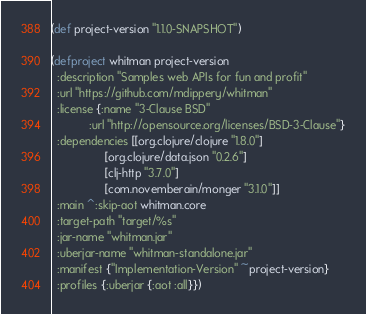Convert code to text. <code><loc_0><loc_0><loc_500><loc_500><_Clojure_>(def project-version "1.1.0-SNAPSHOT")

(defproject whitman project-version
  :description "Samples web APIs for fun and profit"
  :url "https://github.com/mdippery/whitman"
  :license {:name "3-Clause BSD"
            :url "http://opensource.org/licenses/BSD-3-Clause"}
  :dependencies [[org.clojure/clojure "1.8.0"]
                 [org.clojure/data.json "0.2.6"]
                 [clj-http "3.7.0"]
                 [com.novemberain/monger "3.1.0"]]
  :main ^:skip-aot whitman.core
  :target-path "target/%s"
  :jar-name "whitman.jar"
  :uberjar-name "whitman-standalone.jar"
  :manifest {"Implementation-Version" ~project-version}
  :profiles {:uberjar {:aot :all}})
</code> 